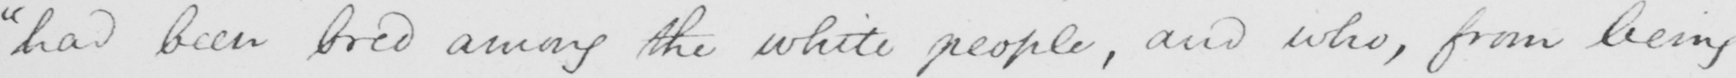What text is written in this handwritten line? "had been bred among the white people, and who, from being 